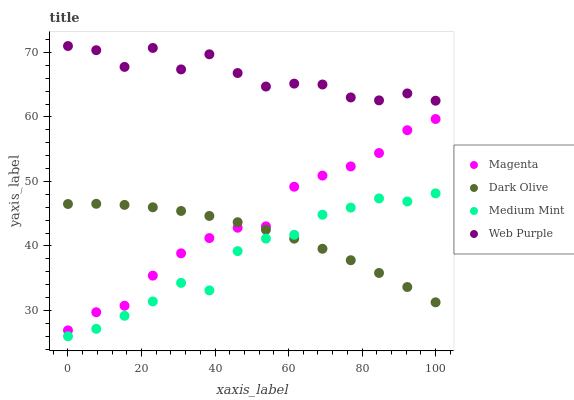Does Medium Mint have the minimum area under the curve?
Answer yes or no. Yes. Does Web Purple have the maximum area under the curve?
Answer yes or no. Yes. Does Magenta have the minimum area under the curve?
Answer yes or no. No. Does Magenta have the maximum area under the curve?
Answer yes or no. No. Is Dark Olive the smoothest?
Answer yes or no. Yes. Is Web Purple the roughest?
Answer yes or no. Yes. Is Magenta the smoothest?
Answer yes or no. No. Is Magenta the roughest?
Answer yes or no. No. Does Medium Mint have the lowest value?
Answer yes or no. Yes. Does Magenta have the lowest value?
Answer yes or no. No. Does Web Purple have the highest value?
Answer yes or no. Yes. Does Magenta have the highest value?
Answer yes or no. No. Is Magenta less than Web Purple?
Answer yes or no. Yes. Is Web Purple greater than Medium Mint?
Answer yes or no. Yes. Does Dark Olive intersect Magenta?
Answer yes or no. Yes. Is Dark Olive less than Magenta?
Answer yes or no. No. Is Dark Olive greater than Magenta?
Answer yes or no. No. Does Magenta intersect Web Purple?
Answer yes or no. No. 